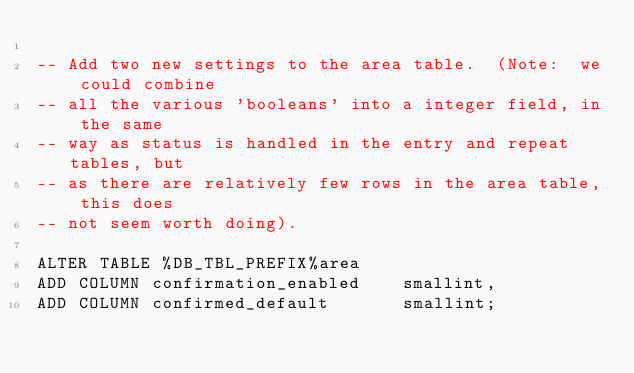<code> <loc_0><loc_0><loc_500><loc_500><_SQL_>
-- Add two new settings to the area table.  (Note:  we could combine
-- all the various 'booleans' into a integer field, in the same
-- way as status is handled in the entry and repeat tables, but
-- as there are relatively few rows in the area table, this does
-- not seem worth doing).

ALTER TABLE %DB_TBL_PREFIX%area 
ADD COLUMN confirmation_enabled    smallint,
ADD COLUMN confirmed_default       smallint;
</code> 